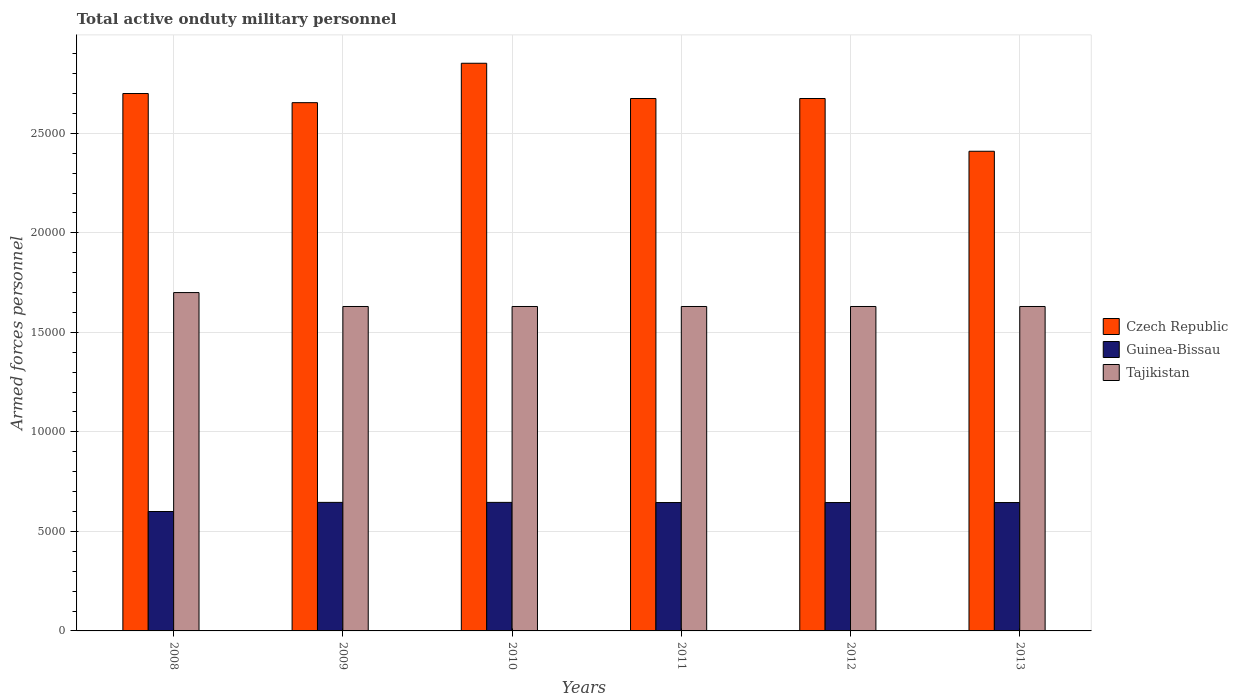How many groups of bars are there?
Offer a very short reply. 6. Are the number of bars per tick equal to the number of legend labels?
Your response must be concise. Yes. How many bars are there on the 5th tick from the right?
Provide a succinct answer. 3. In how many cases, is the number of bars for a given year not equal to the number of legend labels?
Your answer should be very brief. 0. What is the number of armed forces personnel in Guinea-Bissau in 2009?
Your answer should be very brief. 6458. Across all years, what is the maximum number of armed forces personnel in Tajikistan?
Keep it short and to the point. 1.70e+04. Across all years, what is the minimum number of armed forces personnel in Tajikistan?
Your answer should be compact. 1.63e+04. What is the total number of armed forces personnel in Czech Republic in the graph?
Offer a terse response. 1.60e+05. What is the difference between the number of armed forces personnel in Tajikistan in 2010 and that in 2011?
Provide a succinct answer. 0. What is the difference between the number of armed forces personnel in Czech Republic in 2011 and the number of armed forces personnel in Guinea-Bissau in 2012?
Provide a succinct answer. 2.03e+04. What is the average number of armed forces personnel in Czech Republic per year?
Your answer should be compact. 2.66e+04. In the year 2008, what is the difference between the number of armed forces personnel in Czech Republic and number of armed forces personnel in Tajikistan?
Ensure brevity in your answer.  10000. What is the ratio of the number of armed forces personnel in Czech Republic in 2010 to that in 2012?
Provide a succinct answer. 1.07. Is the difference between the number of armed forces personnel in Czech Republic in 2008 and 2012 greater than the difference between the number of armed forces personnel in Tajikistan in 2008 and 2012?
Provide a succinct answer. No. What is the difference between the highest and the second highest number of armed forces personnel in Tajikistan?
Your response must be concise. 700. What is the difference between the highest and the lowest number of armed forces personnel in Czech Republic?
Offer a very short reply. 4421. What does the 3rd bar from the left in 2013 represents?
Provide a short and direct response. Tajikistan. What does the 2nd bar from the right in 2010 represents?
Keep it short and to the point. Guinea-Bissau. How many years are there in the graph?
Offer a very short reply. 6. Where does the legend appear in the graph?
Offer a terse response. Center right. How are the legend labels stacked?
Give a very brief answer. Vertical. What is the title of the graph?
Ensure brevity in your answer.  Total active onduty military personnel. What is the label or title of the X-axis?
Your answer should be very brief. Years. What is the label or title of the Y-axis?
Ensure brevity in your answer.  Armed forces personnel. What is the Armed forces personnel of Czech Republic in 2008?
Your response must be concise. 2.70e+04. What is the Armed forces personnel in Guinea-Bissau in 2008?
Provide a succinct answer. 6000. What is the Armed forces personnel of Tajikistan in 2008?
Ensure brevity in your answer.  1.70e+04. What is the Armed forces personnel of Czech Republic in 2009?
Provide a short and direct response. 2.65e+04. What is the Armed forces personnel in Guinea-Bissau in 2009?
Make the answer very short. 6458. What is the Armed forces personnel in Tajikistan in 2009?
Make the answer very short. 1.63e+04. What is the Armed forces personnel in Czech Republic in 2010?
Your answer should be very brief. 2.85e+04. What is the Armed forces personnel in Guinea-Bissau in 2010?
Offer a very short reply. 6458. What is the Armed forces personnel in Tajikistan in 2010?
Offer a terse response. 1.63e+04. What is the Armed forces personnel in Czech Republic in 2011?
Keep it short and to the point. 2.68e+04. What is the Armed forces personnel of Guinea-Bissau in 2011?
Offer a very short reply. 6450. What is the Armed forces personnel of Tajikistan in 2011?
Provide a short and direct response. 1.63e+04. What is the Armed forces personnel of Czech Republic in 2012?
Your response must be concise. 2.68e+04. What is the Armed forces personnel in Guinea-Bissau in 2012?
Offer a very short reply. 6450. What is the Armed forces personnel of Tajikistan in 2012?
Ensure brevity in your answer.  1.63e+04. What is the Armed forces personnel of Czech Republic in 2013?
Ensure brevity in your answer.  2.41e+04. What is the Armed forces personnel in Guinea-Bissau in 2013?
Your answer should be very brief. 6450. What is the Armed forces personnel of Tajikistan in 2013?
Keep it short and to the point. 1.63e+04. Across all years, what is the maximum Armed forces personnel in Czech Republic?
Provide a short and direct response. 2.85e+04. Across all years, what is the maximum Armed forces personnel in Guinea-Bissau?
Ensure brevity in your answer.  6458. Across all years, what is the maximum Armed forces personnel in Tajikistan?
Ensure brevity in your answer.  1.70e+04. Across all years, what is the minimum Armed forces personnel of Czech Republic?
Your answer should be very brief. 2.41e+04. Across all years, what is the minimum Armed forces personnel in Guinea-Bissau?
Provide a succinct answer. 6000. Across all years, what is the minimum Armed forces personnel in Tajikistan?
Provide a succinct answer. 1.63e+04. What is the total Armed forces personnel in Czech Republic in the graph?
Give a very brief answer. 1.60e+05. What is the total Armed forces personnel of Guinea-Bissau in the graph?
Your response must be concise. 3.83e+04. What is the total Armed forces personnel in Tajikistan in the graph?
Make the answer very short. 9.85e+04. What is the difference between the Armed forces personnel in Czech Republic in 2008 and that in 2009?
Give a very brief answer. 459. What is the difference between the Armed forces personnel in Guinea-Bissau in 2008 and that in 2009?
Your answer should be compact. -458. What is the difference between the Armed forces personnel in Tajikistan in 2008 and that in 2009?
Your answer should be compact. 700. What is the difference between the Armed forces personnel of Czech Republic in 2008 and that in 2010?
Provide a short and direct response. -1521. What is the difference between the Armed forces personnel in Guinea-Bissau in 2008 and that in 2010?
Your answer should be very brief. -458. What is the difference between the Armed forces personnel of Tajikistan in 2008 and that in 2010?
Provide a succinct answer. 700. What is the difference between the Armed forces personnel in Czech Republic in 2008 and that in 2011?
Your answer should be compact. 250. What is the difference between the Armed forces personnel of Guinea-Bissau in 2008 and that in 2011?
Make the answer very short. -450. What is the difference between the Armed forces personnel in Tajikistan in 2008 and that in 2011?
Give a very brief answer. 700. What is the difference between the Armed forces personnel of Czech Republic in 2008 and that in 2012?
Your response must be concise. 250. What is the difference between the Armed forces personnel of Guinea-Bissau in 2008 and that in 2012?
Your answer should be compact. -450. What is the difference between the Armed forces personnel of Tajikistan in 2008 and that in 2012?
Offer a very short reply. 700. What is the difference between the Armed forces personnel in Czech Republic in 2008 and that in 2013?
Offer a terse response. 2900. What is the difference between the Armed forces personnel of Guinea-Bissau in 2008 and that in 2013?
Offer a very short reply. -450. What is the difference between the Armed forces personnel in Tajikistan in 2008 and that in 2013?
Your answer should be very brief. 700. What is the difference between the Armed forces personnel of Czech Republic in 2009 and that in 2010?
Keep it short and to the point. -1980. What is the difference between the Armed forces personnel in Guinea-Bissau in 2009 and that in 2010?
Provide a short and direct response. 0. What is the difference between the Armed forces personnel in Tajikistan in 2009 and that in 2010?
Your answer should be compact. 0. What is the difference between the Armed forces personnel of Czech Republic in 2009 and that in 2011?
Keep it short and to the point. -209. What is the difference between the Armed forces personnel of Guinea-Bissau in 2009 and that in 2011?
Your answer should be compact. 8. What is the difference between the Armed forces personnel of Czech Republic in 2009 and that in 2012?
Ensure brevity in your answer.  -209. What is the difference between the Armed forces personnel in Tajikistan in 2009 and that in 2012?
Provide a succinct answer. 0. What is the difference between the Armed forces personnel in Czech Republic in 2009 and that in 2013?
Provide a succinct answer. 2441. What is the difference between the Armed forces personnel in Guinea-Bissau in 2009 and that in 2013?
Offer a terse response. 8. What is the difference between the Armed forces personnel of Tajikistan in 2009 and that in 2013?
Your response must be concise. 0. What is the difference between the Armed forces personnel of Czech Republic in 2010 and that in 2011?
Offer a very short reply. 1771. What is the difference between the Armed forces personnel of Tajikistan in 2010 and that in 2011?
Your answer should be compact. 0. What is the difference between the Armed forces personnel of Czech Republic in 2010 and that in 2012?
Offer a terse response. 1771. What is the difference between the Armed forces personnel of Tajikistan in 2010 and that in 2012?
Your response must be concise. 0. What is the difference between the Armed forces personnel in Czech Republic in 2010 and that in 2013?
Give a very brief answer. 4421. What is the difference between the Armed forces personnel in Tajikistan in 2010 and that in 2013?
Make the answer very short. 0. What is the difference between the Armed forces personnel in Czech Republic in 2011 and that in 2012?
Keep it short and to the point. 0. What is the difference between the Armed forces personnel of Tajikistan in 2011 and that in 2012?
Your answer should be compact. 0. What is the difference between the Armed forces personnel of Czech Republic in 2011 and that in 2013?
Offer a terse response. 2650. What is the difference between the Armed forces personnel of Guinea-Bissau in 2011 and that in 2013?
Your answer should be very brief. 0. What is the difference between the Armed forces personnel of Tajikistan in 2011 and that in 2013?
Provide a short and direct response. 0. What is the difference between the Armed forces personnel of Czech Republic in 2012 and that in 2013?
Offer a terse response. 2650. What is the difference between the Armed forces personnel in Guinea-Bissau in 2012 and that in 2013?
Your response must be concise. 0. What is the difference between the Armed forces personnel in Tajikistan in 2012 and that in 2013?
Ensure brevity in your answer.  0. What is the difference between the Armed forces personnel in Czech Republic in 2008 and the Armed forces personnel in Guinea-Bissau in 2009?
Ensure brevity in your answer.  2.05e+04. What is the difference between the Armed forces personnel in Czech Republic in 2008 and the Armed forces personnel in Tajikistan in 2009?
Offer a terse response. 1.07e+04. What is the difference between the Armed forces personnel in Guinea-Bissau in 2008 and the Armed forces personnel in Tajikistan in 2009?
Offer a terse response. -1.03e+04. What is the difference between the Armed forces personnel in Czech Republic in 2008 and the Armed forces personnel in Guinea-Bissau in 2010?
Your response must be concise. 2.05e+04. What is the difference between the Armed forces personnel in Czech Republic in 2008 and the Armed forces personnel in Tajikistan in 2010?
Give a very brief answer. 1.07e+04. What is the difference between the Armed forces personnel of Guinea-Bissau in 2008 and the Armed forces personnel of Tajikistan in 2010?
Your response must be concise. -1.03e+04. What is the difference between the Armed forces personnel in Czech Republic in 2008 and the Armed forces personnel in Guinea-Bissau in 2011?
Provide a succinct answer. 2.06e+04. What is the difference between the Armed forces personnel of Czech Republic in 2008 and the Armed forces personnel of Tajikistan in 2011?
Keep it short and to the point. 1.07e+04. What is the difference between the Armed forces personnel of Guinea-Bissau in 2008 and the Armed forces personnel of Tajikistan in 2011?
Provide a short and direct response. -1.03e+04. What is the difference between the Armed forces personnel in Czech Republic in 2008 and the Armed forces personnel in Guinea-Bissau in 2012?
Your answer should be compact. 2.06e+04. What is the difference between the Armed forces personnel in Czech Republic in 2008 and the Armed forces personnel in Tajikistan in 2012?
Make the answer very short. 1.07e+04. What is the difference between the Armed forces personnel of Guinea-Bissau in 2008 and the Armed forces personnel of Tajikistan in 2012?
Your answer should be compact. -1.03e+04. What is the difference between the Armed forces personnel of Czech Republic in 2008 and the Armed forces personnel of Guinea-Bissau in 2013?
Provide a short and direct response. 2.06e+04. What is the difference between the Armed forces personnel of Czech Republic in 2008 and the Armed forces personnel of Tajikistan in 2013?
Your answer should be very brief. 1.07e+04. What is the difference between the Armed forces personnel of Guinea-Bissau in 2008 and the Armed forces personnel of Tajikistan in 2013?
Offer a terse response. -1.03e+04. What is the difference between the Armed forces personnel in Czech Republic in 2009 and the Armed forces personnel in Guinea-Bissau in 2010?
Provide a succinct answer. 2.01e+04. What is the difference between the Armed forces personnel of Czech Republic in 2009 and the Armed forces personnel of Tajikistan in 2010?
Provide a succinct answer. 1.02e+04. What is the difference between the Armed forces personnel of Guinea-Bissau in 2009 and the Armed forces personnel of Tajikistan in 2010?
Offer a terse response. -9842. What is the difference between the Armed forces personnel in Czech Republic in 2009 and the Armed forces personnel in Guinea-Bissau in 2011?
Provide a short and direct response. 2.01e+04. What is the difference between the Armed forces personnel of Czech Republic in 2009 and the Armed forces personnel of Tajikistan in 2011?
Offer a terse response. 1.02e+04. What is the difference between the Armed forces personnel of Guinea-Bissau in 2009 and the Armed forces personnel of Tajikistan in 2011?
Make the answer very short. -9842. What is the difference between the Armed forces personnel of Czech Republic in 2009 and the Armed forces personnel of Guinea-Bissau in 2012?
Make the answer very short. 2.01e+04. What is the difference between the Armed forces personnel of Czech Republic in 2009 and the Armed forces personnel of Tajikistan in 2012?
Your response must be concise. 1.02e+04. What is the difference between the Armed forces personnel of Guinea-Bissau in 2009 and the Armed forces personnel of Tajikistan in 2012?
Ensure brevity in your answer.  -9842. What is the difference between the Armed forces personnel in Czech Republic in 2009 and the Armed forces personnel in Guinea-Bissau in 2013?
Give a very brief answer. 2.01e+04. What is the difference between the Armed forces personnel in Czech Republic in 2009 and the Armed forces personnel in Tajikistan in 2013?
Your answer should be compact. 1.02e+04. What is the difference between the Armed forces personnel of Guinea-Bissau in 2009 and the Armed forces personnel of Tajikistan in 2013?
Your response must be concise. -9842. What is the difference between the Armed forces personnel of Czech Republic in 2010 and the Armed forces personnel of Guinea-Bissau in 2011?
Your response must be concise. 2.21e+04. What is the difference between the Armed forces personnel of Czech Republic in 2010 and the Armed forces personnel of Tajikistan in 2011?
Offer a terse response. 1.22e+04. What is the difference between the Armed forces personnel in Guinea-Bissau in 2010 and the Armed forces personnel in Tajikistan in 2011?
Keep it short and to the point. -9842. What is the difference between the Armed forces personnel of Czech Republic in 2010 and the Armed forces personnel of Guinea-Bissau in 2012?
Offer a very short reply. 2.21e+04. What is the difference between the Armed forces personnel in Czech Republic in 2010 and the Armed forces personnel in Tajikistan in 2012?
Make the answer very short. 1.22e+04. What is the difference between the Armed forces personnel of Guinea-Bissau in 2010 and the Armed forces personnel of Tajikistan in 2012?
Give a very brief answer. -9842. What is the difference between the Armed forces personnel in Czech Republic in 2010 and the Armed forces personnel in Guinea-Bissau in 2013?
Your answer should be compact. 2.21e+04. What is the difference between the Armed forces personnel in Czech Republic in 2010 and the Armed forces personnel in Tajikistan in 2013?
Provide a short and direct response. 1.22e+04. What is the difference between the Armed forces personnel in Guinea-Bissau in 2010 and the Armed forces personnel in Tajikistan in 2013?
Offer a very short reply. -9842. What is the difference between the Armed forces personnel of Czech Republic in 2011 and the Armed forces personnel of Guinea-Bissau in 2012?
Give a very brief answer. 2.03e+04. What is the difference between the Armed forces personnel of Czech Republic in 2011 and the Armed forces personnel of Tajikistan in 2012?
Your answer should be compact. 1.04e+04. What is the difference between the Armed forces personnel of Guinea-Bissau in 2011 and the Armed forces personnel of Tajikistan in 2012?
Your answer should be compact. -9850. What is the difference between the Armed forces personnel in Czech Republic in 2011 and the Armed forces personnel in Guinea-Bissau in 2013?
Your answer should be very brief. 2.03e+04. What is the difference between the Armed forces personnel in Czech Republic in 2011 and the Armed forces personnel in Tajikistan in 2013?
Ensure brevity in your answer.  1.04e+04. What is the difference between the Armed forces personnel of Guinea-Bissau in 2011 and the Armed forces personnel of Tajikistan in 2013?
Your answer should be very brief. -9850. What is the difference between the Armed forces personnel in Czech Republic in 2012 and the Armed forces personnel in Guinea-Bissau in 2013?
Offer a terse response. 2.03e+04. What is the difference between the Armed forces personnel of Czech Republic in 2012 and the Armed forces personnel of Tajikistan in 2013?
Give a very brief answer. 1.04e+04. What is the difference between the Armed forces personnel in Guinea-Bissau in 2012 and the Armed forces personnel in Tajikistan in 2013?
Provide a short and direct response. -9850. What is the average Armed forces personnel of Czech Republic per year?
Your answer should be compact. 2.66e+04. What is the average Armed forces personnel of Guinea-Bissau per year?
Offer a terse response. 6377.67. What is the average Armed forces personnel of Tajikistan per year?
Offer a terse response. 1.64e+04. In the year 2008, what is the difference between the Armed forces personnel in Czech Republic and Armed forces personnel in Guinea-Bissau?
Ensure brevity in your answer.  2.10e+04. In the year 2008, what is the difference between the Armed forces personnel of Czech Republic and Armed forces personnel of Tajikistan?
Give a very brief answer. 10000. In the year 2008, what is the difference between the Armed forces personnel of Guinea-Bissau and Armed forces personnel of Tajikistan?
Ensure brevity in your answer.  -1.10e+04. In the year 2009, what is the difference between the Armed forces personnel of Czech Republic and Armed forces personnel of Guinea-Bissau?
Offer a terse response. 2.01e+04. In the year 2009, what is the difference between the Armed forces personnel in Czech Republic and Armed forces personnel in Tajikistan?
Keep it short and to the point. 1.02e+04. In the year 2009, what is the difference between the Armed forces personnel of Guinea-Bissau and Armed forces personnel of Tajikistan?
Ensure brevity in your answer.  -9842. In the year 2010, what is the difference between the Armed forces personnel in Czech Republic and Armed forces personnel in Guinea-Bissau?
Keep it short and to the point. 2.21e+04. In the year 2010, what is the difference between the Armed forces personnel in Czech Republic and Armed forces personnel in Tajikistan?
Offer a terse response. 1.22e+04. In the year 2010, what is the difference between the Armed forces personnel of Guinea-Bissau and Armed forces personnel of Tajikistan?
Offer a very short reply. -9842. In the year 2011, what is the difference between the Armed forces personnel in Czech Republic and Armed forces personnel in Guinea-Bissau?
Offer a terse response. 2.03e+04. In the year 2011, what is the difference between the Armed forces personnel of Czech Republic and Armed forces personnel of Tajikistan?
Offer a terse response. 1.04e+04. In the year 2011, what is the difference between the Armed forces personnel in Guinea-Bissau and Armed forces personnel in Tajikistan?
Your answer should be compact. -9850. In the year 2012, what is the difference between the Armed forces personnel in Czech Republic and Armed forces personnel in Guinea-Bissau?
Make the answer very short. 2.03e+04. In the year 2012, what is the difference between the Armed forces personnel of Czech Republic and Armed forces personnel of Tajikistan?
Your answer should be very brief. 1.04e+04. In the year 2012, what is the difference between the Armed forces personnel of Guinea-Bissau and Armed forces personnel of Tajikistan?
Your response must be concise. -9850. In the year 2013, what is the difference between the Armed forces personnel of Czech Republic and Armed forces personnel of Guinea-Bissau?
Offer a terse response. 1.76e+04. In the year 2013, what is the difference between the Armed forces personnel of Czech Republic and Armed forces personnel of Tajikistan?
Ensure brevity in your answer.  7800. In the year 2013, what is the difference between the Armed forces personnel in Guinea-Bissau and Armed forces personnel in Tajikistan?
Make the answer very short. -9850. What is the ratio of the Armed forces personnel of Czech Republic in 2008 to that in 2009?
Provide a succinct answer. 1.02. What is the ratio of the Armed forces personnel of Guinea-Bissau in 2008 to that in 2009?
Make the answer very short. 0.93. What is the ratio of the Armed forces personnel in Tajikistan in 2008 to that in 2009?
Provide a short and direct response. 1.04. What is the ratio of the Armed forces personnel of Czech Republic in 2008 to that in 2010?
Your response must be concise. 0.95. What is the ratio of the Armed forces personnel in Guinea-Bissau in 2008 to that in 2010?
Ensure brevity in your answer.  0.93. What is the ratio of the Armed forces personnel in Tajikistan in 2008 to that in 2010?
Make the answer very short. 1.04. What is the ratio of the Armed forces personnel of Czech Republic in 2008 to that in 2011?
Offer a very short reply. 1.01. What is the ratio of the Armed forces personnel in Guinea-Bissau in 2008 to that in 2011?
Make the answer very short. 0.93. What is the ratio of the Armed forces personnel of Tajikistan in 2008 to that in 2011?
Offer a very short reply. 1.04. What is the ratio of the Armed forces personnel of Czech Republic in 2008 to that in 2012?
Make the answer very short. 1.01. What is the ratio of the Armed forces personnel in Guinea-Bissau in 2008 to that in 2012?
Your answer should be compact. 0.93. What is the ratio of the Armed forces personnel of Tajikistan in 2008 to that in 2012?
Ensure brevity in your answer.  1.04. What is the ratio of the Armed forces personnel in Czech Republic in 2008 to that in 2013?
Give a very brief answer. 1.12. What is the ratio of the Armed forces personnel of Guinea-Bissau in 2008 to that in 2013?
Provide a succinct answer. 0.93. What is the ratio of the Armed forces personnel of Tajikistan in 2008 to that in 2013?
Provide a succinct answer. 1.04. What is the ratio of the Armed forces personnel in Czech Republic in 2009 to that in 2010?
Provide a short and direct response. 0.93. What is the ratio of the Armed forces personnel of Guinea-Bissau in 2009 to that in 2010?
Offer a terse response. 1. What is the ratio of the Armed forces personnel in Czech Republic in 2009 to that in 2011?
Ensure brevity in your answer.  0.99. What is the ratio of the Armed forces personnel in Guinea-Bissau in 2009 to that in 2011?
Provide a succinct answer. 1. What is the ratio of the Armed forces personnel of Guinea-Bissau in 2009 to that in 2012?
Keep it short and to the point. 1. What is the ratio of the Armed forces personnel of Tajikistan in 2009 to that in 2012?
Keep it short and to the point. 1. What is the ratio of the Armed forces personnel of Czech Republic in 2009 to that in 2013?
Give a very brief answer. 1.1. What is the ratio of the Armed forces personnel of Tajikistan in 2009 to that in 2013?
Your answer should be very brief. 1. What is the ratio of the Armed forces personnel of Czech Republic in 2010 to that in 2011?
Your answer should be compact. 1.07. What is the ratio of the Armed forces personnel of Tajikistan in 2010 to that in 2011?
Offer a terse response. 1. What is the ratio of the Armed forces personnel of Czech Republic in 2010 to that in 2012?
Provide a short and direct response. 1.07. What is the ratio of the Armed forces personnel of Guinea-Bissau in 2010 to that in 2012?
Offer a terse response. 1. What is the ratio of the Armed forces personnel in Tajikistan in 2010 to that in 2012?
Your response must be concise. 1. What is the ratio of the Armed forces personnel in Czech Republic in 2010 to that in 2013?
Keep it short and to the point. 1.18. What is the ratio of the Armed forces personnel in Czech Republic in 2011 to that in 2013?
Your answer should be very brief. 1.11. What is the ratio of the Armed forces personnel in Tajikistan in 2011 to that in 2013?
Offer a very short reply. 1. What is the ratio of the Armed forces personnel in Czech Republic in 2012 to that in 2013?
Your answer should be compact. 1.11. What is the ratio of the Armed forces personnel of Tajikistan in 2012 to that in 2013?
Ensure brevity in your answer.  1. What is the difference between the highest and the second highest Armed forces personnel in Czech Republic?
Offer a terse response. 1521. What is the difference between the highest and the second highest Armed forces personnel of Guinea-Bissau?
Provide a short and direct response. 0. What is the difference between the highest and the second highest Armed forces personnel of Tajikistan?
Offer a terse response. 700. What is the difference between the highest and the lowest Armed forces personnel in Czech Republic?
Make the answer very short. 4421. What is the difference between the highest and the lowest Armed forces personnel in Guinea-Bissau?
Give a very brief answer. 458. What is the difference between the highest and the lowest Armed forces personnel in Tajikistan?
Your answer should be very brief. 700. 